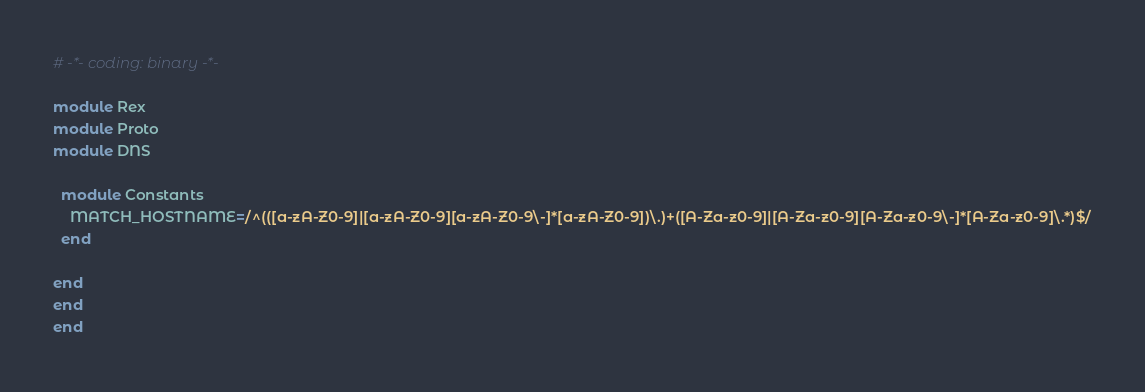<code> <loc_0><loc_0><loc_500><loc_500><_Ruby_># -*- coding: binary -*-

module Rex
module Proto
module DNS

  module Constants
    MATCH_HOSTNAME=/^(([a-zA-Z0-9]|[a-zA-Z0-9][a-zA-Z0-9\-]*[a-zA-Z0-9])\.)+([A-Za-z0-9]|[A-Za-z0-9][A-Za-z0-9\-]*[A-Za-z0-9]\.*)$/
  end

end
end
end

</code> 